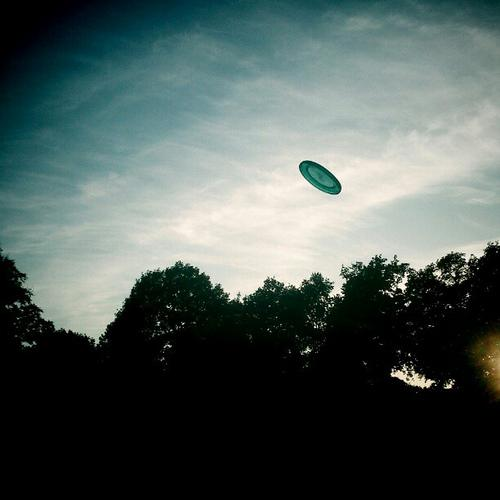Question: what does the sky look?
Choices:
A. Sunny.
B. Cloudy.
C. Rainy.
D. Windy.
Answer with the letter. Answer: B Question: why is the frisbee in the air?
Choices:
A. An ultimate game.
B. A frisbee flies.
C. Someone threw it.
D. It was thrown.
Answer with the letter. Answer: D Question: what color is the frisbee?
Choices:
A. Blue.
B. White.
C. Green.
D. Black.
Answer with the letter. Answer: C Question: when was the picture taken?
Choices:
A. Morning.
B. Afternnon.
C. Early evening.
D. Midnight.
Answer with the letter. Answer: C Question: who is in the picture?
Choices:
A. A boy.
B. A family.
C. No people are shown.
D. A husband & wife.
Answer with the letter. Answer: C Question: what is in the background?
Choices:
A. Sky.
B. Clouds.
C. Trees.
D. Buildings.
Answer with the letter. Answer: C 